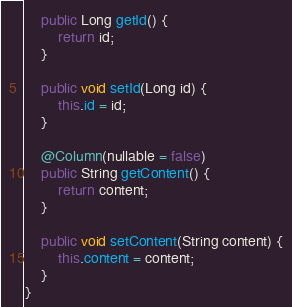<code> <loc_0><loc_0><loc_500><loc_500><_Java_>    public Long getId() {
        return id;
    }

    public void setId(Long id) {
        this.id = id;
    }

    @Column(nullable = false)
    public String getContent() {
        return content;
    }

    public void setContent(String content) {
        this.content = content;
    }
}
</code> 